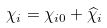<formula> <loc_0><loc_0><loc_500><loc_500>\chi _ { i } = \chi _ { i 0 } + \widehat { \chi } _ { i }</formula> 